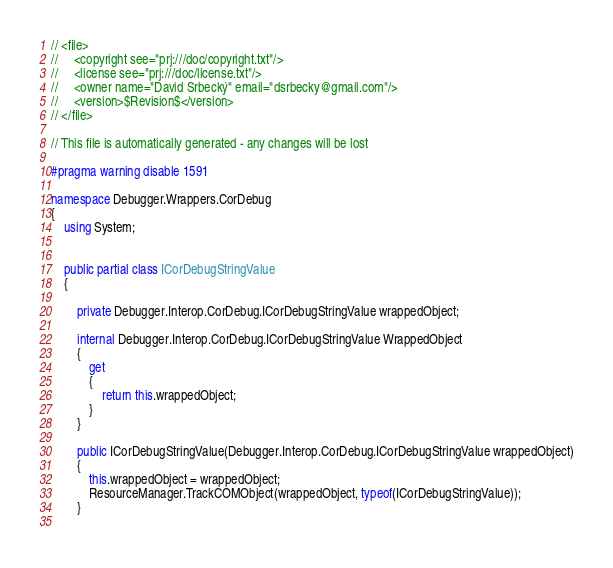<code> <loc_0><loc_0><loc_500><loc_500><_C#_>// <file>
//     <copyright see="prj:///doc/copyright.txt"/>
//     <license see="prj:///doc/license.txt"/>
//     <owner name="David Srbecký" email="dsrbecky@gmail.com"/>
//     <version>$Revision$</version>
// </file>

// This file is automatically generated - any changes will be lost

#pragma warning disable 1591

namespace Debugger.Wrappers.CorDebug
{
	using System;
	
	
	public partial class ICorDebugStringValue
	{
		
		private Debugger.Interop.CorDebug.ICorDebugStringValue wrappedObject;
		
		internal Debugger.Interop.CorDebug.ICorDebugStringValue WrappedObject
		{
			get
			{
				return this.wrappedObject;
			}
		}
		
		public ICorDebugStringValue(Debugger.Interop.CorDebug.ICorDebugStringValue wrappedObject)
		{
			this.wrappedObject = wrappedObject;
			ResourceManager.TrackCOMObject(wrappedObject, typeof(ICorDebugStringValue));
		}
		</code> 